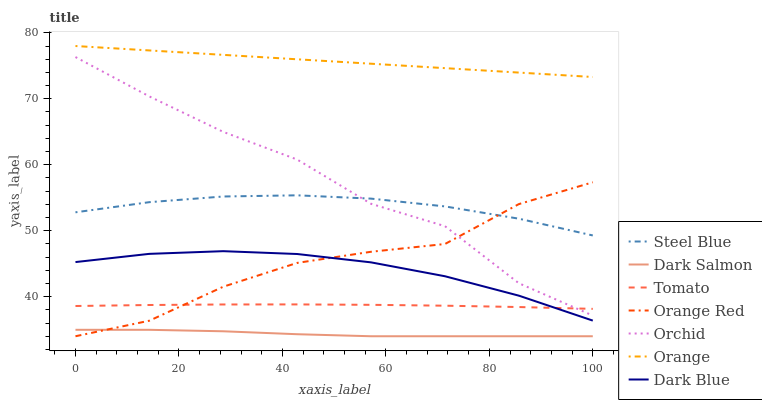Does Steel Blue have the minimum area under the curve?
Answer yes or no. No. Does Steel Blue have the maximum area under the curve?
Answer yes or no. No. Is Steel Blue the smoothest?
Answer yes or no. No. Is Steel Blue the roughest?
Answer yes or no. No. Does Steel Blue have the lowest value?
Answer yes or no. No. Does Steel Blue have the highest value?
Answer yes or no. No. Is Dark Salmon less than Orange?
Answer yes or no. Yes. Is Orange greater than Orchid?
Answer yes or no. Yes. Does Dark Salmon intersect Orange?
Answer yes or no. No. 